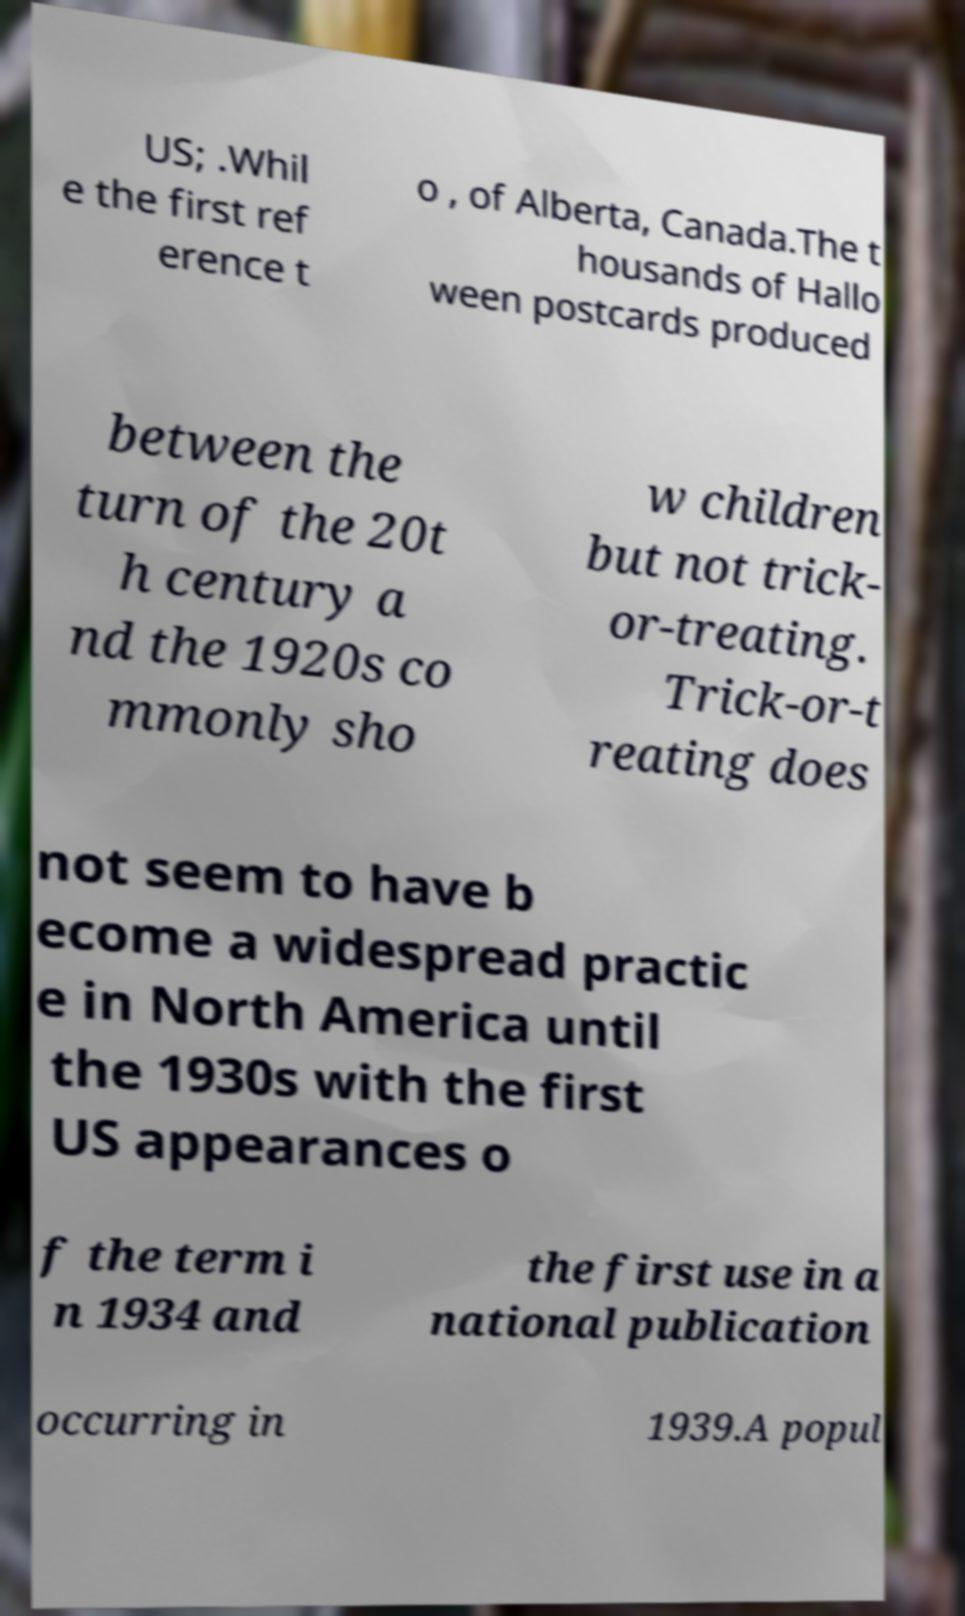I need the written content from this picture converted into text. Can you do that? US; .Whil e the first ref erence t o , of Alberta, Canada.The t housands of Hallo ween postcards produced between the turn of the 20t h century a nd the 1920s co mmonly sho w children but not trick- or-treating. Trick-or-t reating does not seem to have b ecome a widespread practic e in North America until the 1930s with the first US appearances o f the term i n 1934 and the first use in a national publication occurring in 1939.A popul 